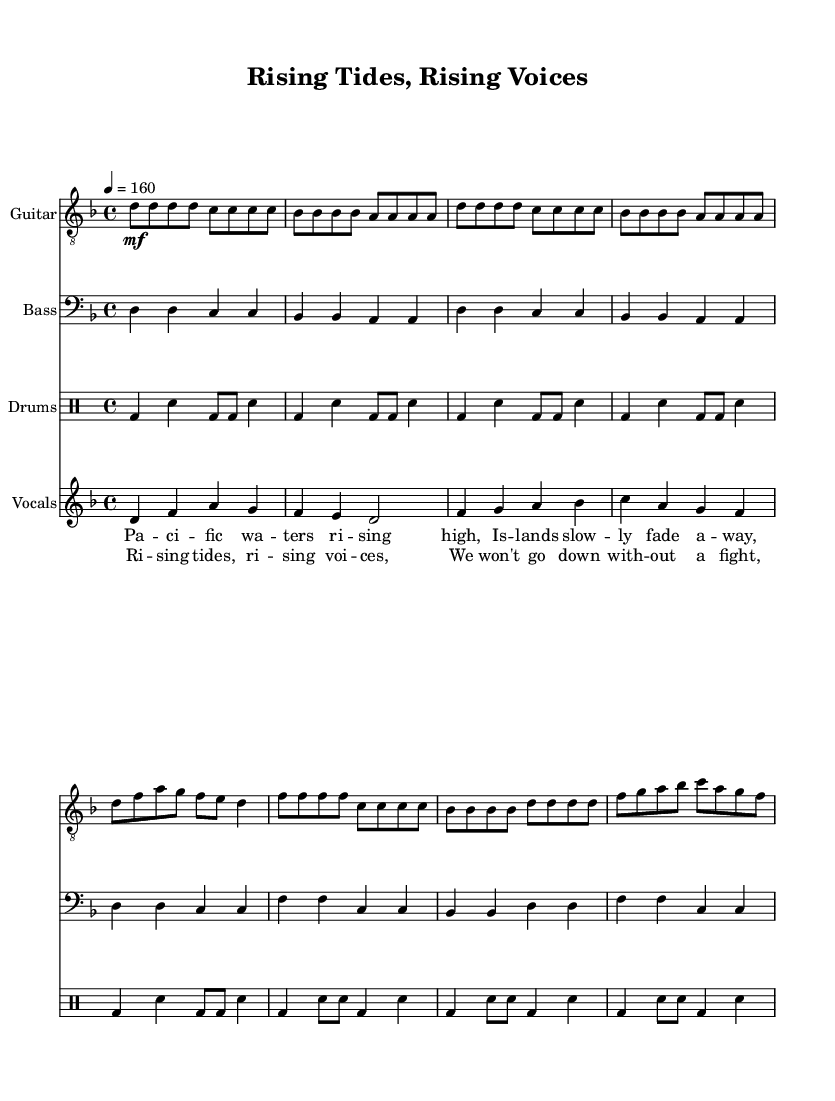What is the time signature of this music? The time signature is notated at the start of the music as 4/4, indicating four beats per measure with a quarter note as one beat.
Answer: 4/4 What is the key signature of this music? The key signature appears at the beginning with one flat, indicating that the music is in D minor, as it is the relative minor of F major.
Answer: D minor What is the tempo marking of the piece? The tempo marking is indicated as '4 = 160', meaning that there are 160 quarter note beats per minute, which defines the speed of the music.
Answer: 160 How many measures are in the chorus? The chorus consists of four measures spread across the lyrical section, as determined by counting the measures outlined in the musical score.
Answer: 4 Which instruments are present in the score? The score includes guitar, bass, drums, and vocals, as listed at the start of each staff section and in the new Staff and DrumStaff notations.
Answer: Guitar, Bass, Drums, Vocals What is the primary lyrical theme of the song? The lyrics highlight the urgent issue of climate change affecting Pacific islands, stating that "Islands slowly fade away," which reflects environmental concerns.
Answer: Climate change How does the vocal melody of the chorus compare to that of the verse? The vocal melody for the chorus features a higher pitch range and a more intense rhythmic structure than that of the verse, emphasizing a call to action through stronger motifs.
Answer: Higher pitch, more intensity 